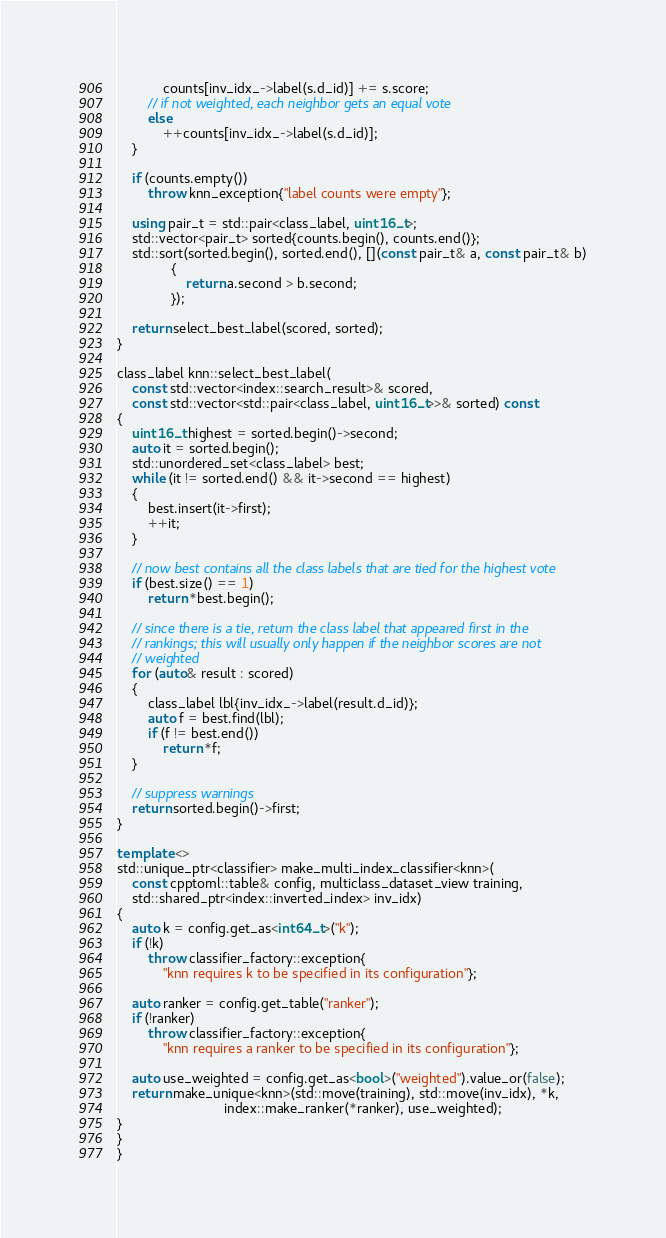<code> <loc_0><loc_0><loc_500><loc_500><_C++_>            counts[inv_idx_->label(s.d_id)] += s.score;
        // if not weighted, each neighbor gets an equal vote
        else
            ++counts[inv_idx_->label(s.d_id)];
    }

    if (counts.empty())
        throw knn_exception{"label counts were empty"};

    using pair_t = std::pair<class_label, uint16_t>;
    std::vector<pair_t> sorted{counts.begin(), counts.end()};
    std::sort(sorted.begin(), sorted.end(), [](const pair_t& a, const pair_t& b)
              {
                  return a.second > b.second;
              });

    return select_best_label(scored, sorted);
}

class_label knn::select_best_label(
    const std::vector<index::search_result>& scored,
    const std::vector<std::pair<class_label, uint16_t>>& sorted) const
{
    uint16_t highest = sorted.begin()->second;
    auto it = sorted.begin();
    std::unordered_set<class_label> best;
    while (it != sorted.end() && it->second == highest)
    {
        best.insert(it->first);
        ++it;
    }

    // now best contains all the class labels that are tied for the highest vote
    if (best.size() == 1)
        return *best.begin();

    // since there is a tie, return the class label that appeared first in the
    // rankings; this will usually only happen if the neighbor scores are not
    // weighted
    for (auto& result : scored)
    {
        class_label lbl{inv_idx_->label(result.d_id)};
        auto f = best.find(lbl);
        if (f != best.end())
            return *f;
    }

    // suppress warnings
    return sorted.begin()->first;
}

template <>
std::unique_ptr<classifier> make_multi_index_classifier<knn>(
    const cpptoml::table& config, multiclass_dataset_view training,
    std::shared_ptr<index::inverted_index> inv_idx)
{
    auto k = config.get_as<int64_t>("k");
    if (!k)
        throw classifier_factory::exception{
            "knn requires k to be specified in its configuration"};

    auto ranker = config.get_table("ranker");
    if (!ranker)
        throw classifier_factory::exception{
            "knn requires a ranker to be specified in its configuration"};

    auto use_weighted = config.get_as<bool>("weighted").value_or(false);
    return make_unique<knn>(std::move(training), std::move(inv_idx), *k,
                            index::make_ranker(*ranker), use_weighted);
}
}
}
</code> 